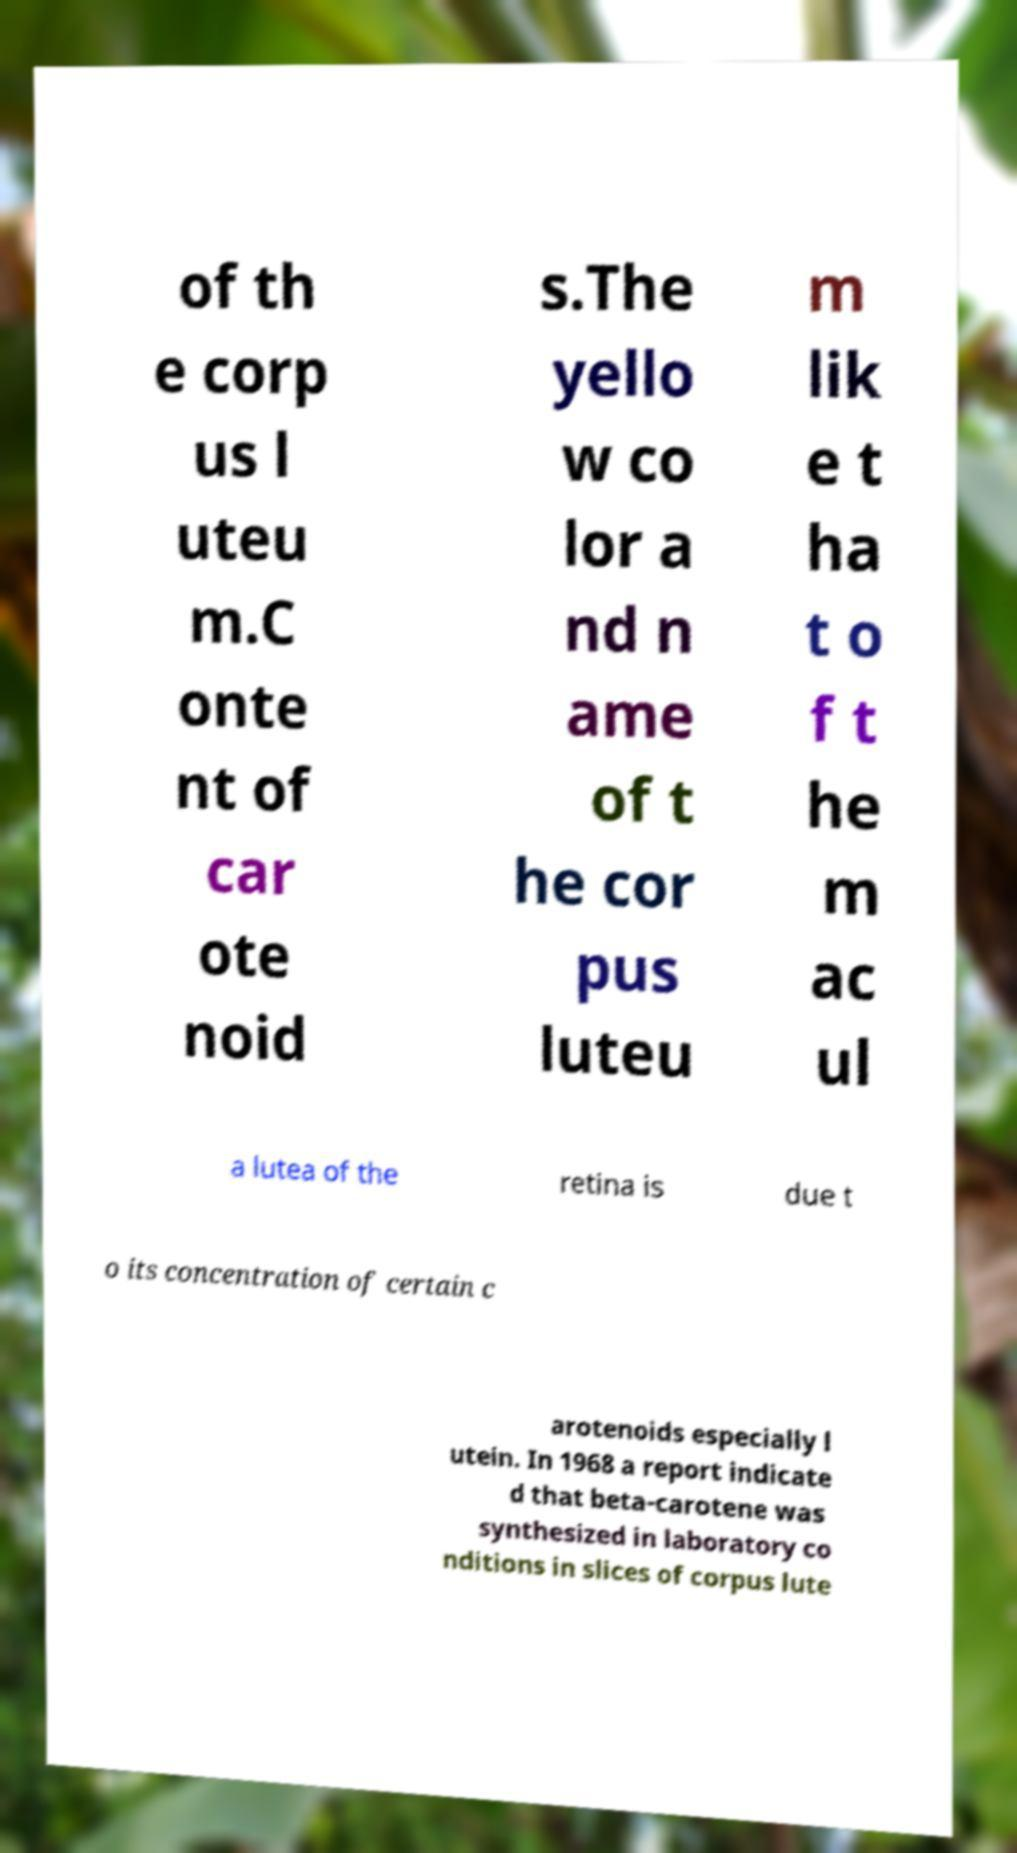Please read and relay the text visible in this image. What does it say? of th e corp us l uteu m.C onte nt of car ote noid s.The yello w co lor a nd n ame of t he cor pus luteu m lik e t ha t o f t he m ac ul a lutea of the retina is due t o its concentration of certain c arotenoids especially l utein. In 1968 a report indicate d that beta-carotene was synthesized in laboratory co nditions in slices of corpus lute 